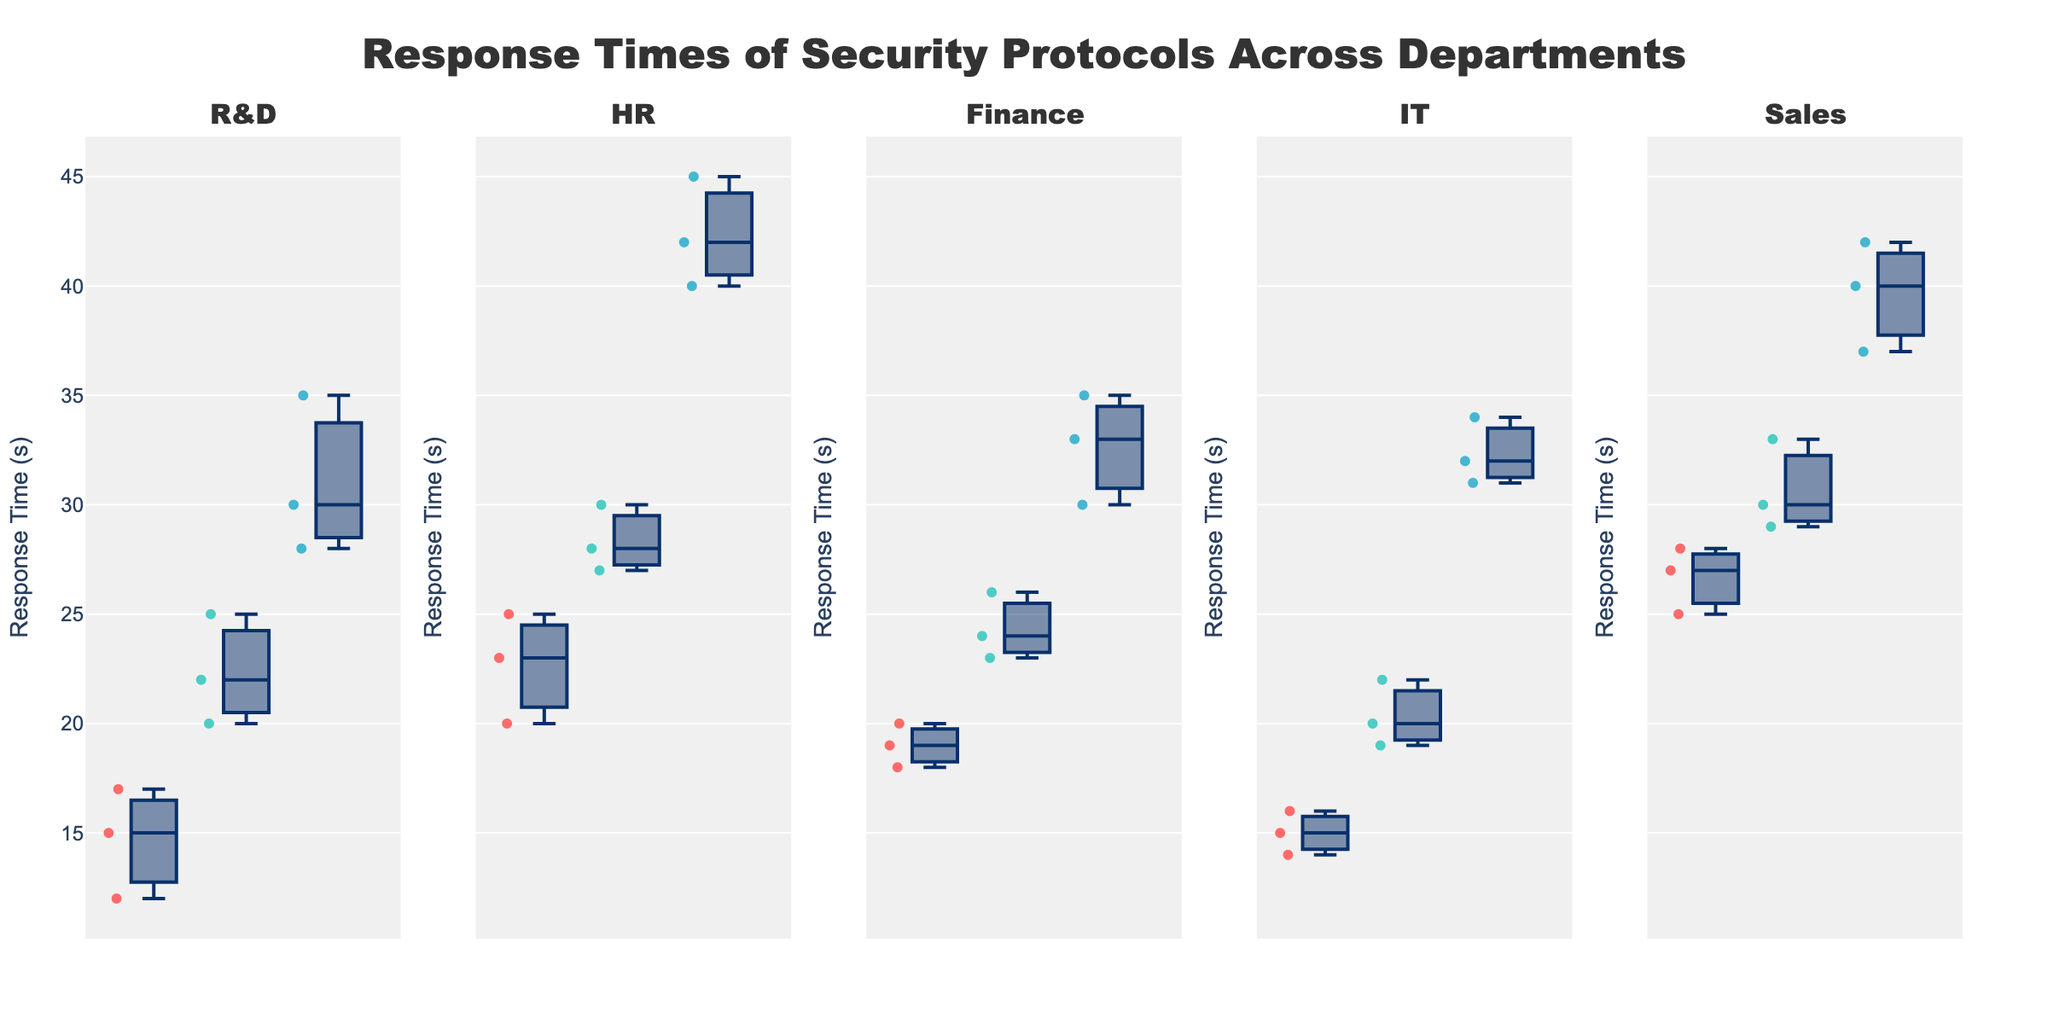What is the title of the figure? The title is displayed at the top center of the figure's layout, generally in a larger font size and in a distinguishable color.
Answer: Response Times of Security Protocols Across Departments How many different security protocols are compared in the figure? By observing the legend or the labels within each box plot, we can count the number of unique protocols being compared across all subplots.
Answer: 3 Which department has the highest median response time for Multi-Factor Authentication? Look for the box plot that represents Multi-Factor Authentication in each department's subplot and compare their median lines (usually indicated by a line within the box).
Answer: HR What color represents the Firewall protocol in the figure? Identify the color assigned to the Firewall protocol by checking any of the box plots corresponding to Firewall in any department's subplot.
Answer: Red Which department has the lowest range of response times for Encryption? Examine the length of the boxes (from the bottom of the lower whisker to the top of the upper whisker) for Encryption protocol in each department's subplot. The smallest range indicates the lowest variability.
Answer: IT Which protocol generally takes the longest to respond in the Sales department? Look at the positions of the median lines and the overall spread of the box plots for each protocol within the Sales department's subplot. The protocol with the highest median or the box plot positioned higher vertically generally takes the longest.
Answer: Multi-Factor Authentication What's the interquartile range (IQR) of Response Times for Firewall in the R&D department? First find the lower quartile (Q1) and the upper quartile (Q3) by examining the ends of the box, then compute the difference Q3 - Q1.
Answer: 5 (Q3=17, Q1=12) How do Response Times for Encryption in Finance compare to those in R&D? Compare the medians and the overall spread (IQR) of the Encryption protocol’s box plots between Finance and R&D departments.
Answer: Lower in Finance Which protocol shows the most variability in the Finance department? Identify the protocol with the widest box plot (largest range between the bottom of the lower whisker and the top of the upper whisker).
Answer: Multi-Factor Authentication What is the median response time for Firewall in the Sales department? Find the line that divides the box plot of Firewall in the Sales subplot into two equal parts.
Answer: 27 